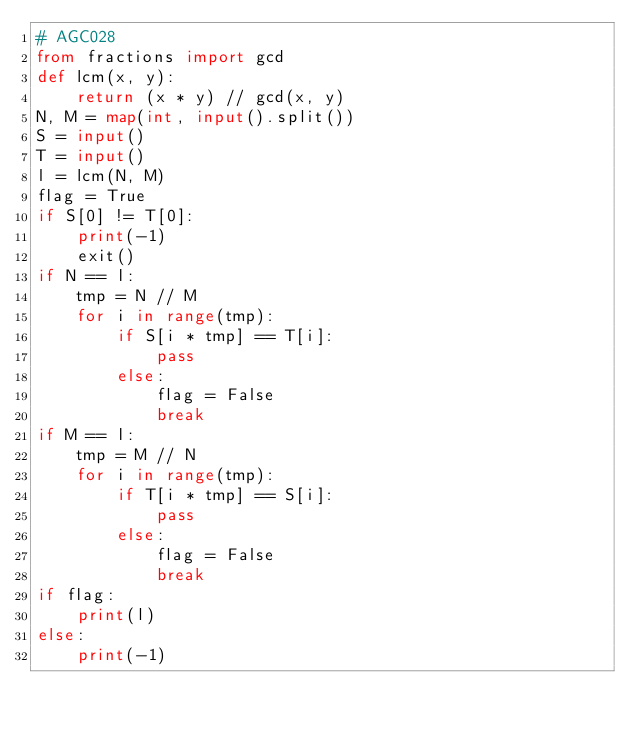<code> <loc_0><loc_0><loc_500><loc_500><_Python_># AGC028
from fractions import gcd
def lcm(x, y):
    return (x * y) // gcd(x, y)
N, M = map(int, input().split())
S = input()
T = input()
l = lcm(N, M)
flag = True
if S[0] != T[0]:
    print(-1)
    exit()
if N == l:
    tmp = N // M
    for i in range(tmp):
        if S[i * tmp] == T[i]:
            pass
        else:
            flag = False
            break
if M == l:
    tmp = M // N
    for i in range(tmp):
        if T[i * tmp] == S[i]:
            pass
        else:
            flag = False
            break
if flag:
    print(l)
else:
    print(-1)</code> 